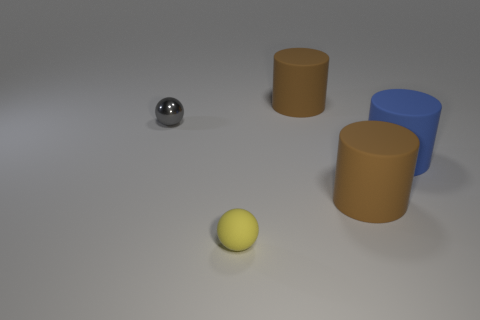Add 4 yellow balls. How many objects exist? 9 Subtract all spheres. How many objects are left? 3 Add 2 tiny balls. How many tiny balls exist? 4 Subtract 0 red cylinders. How many objects are left? 5 Subtract all small gray spheres. Subtract all small gray shiny objects. How many objects are left? 3 Add 1 small things. How many small things are left? 3 